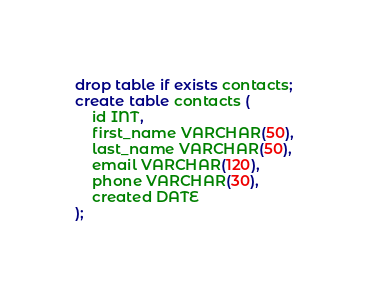Convert code to text. <code><loc_0><loc_0><loc_500><loc_500><_SQL_>drop table if exists contacts;
create table contacts (
	id INT,
	first_name VARCHAR(50),
	last_name VARCHAR(50),
	email VARCHAR(120),
	phone VARCHAR(30),
	created DATE
);
</code> 